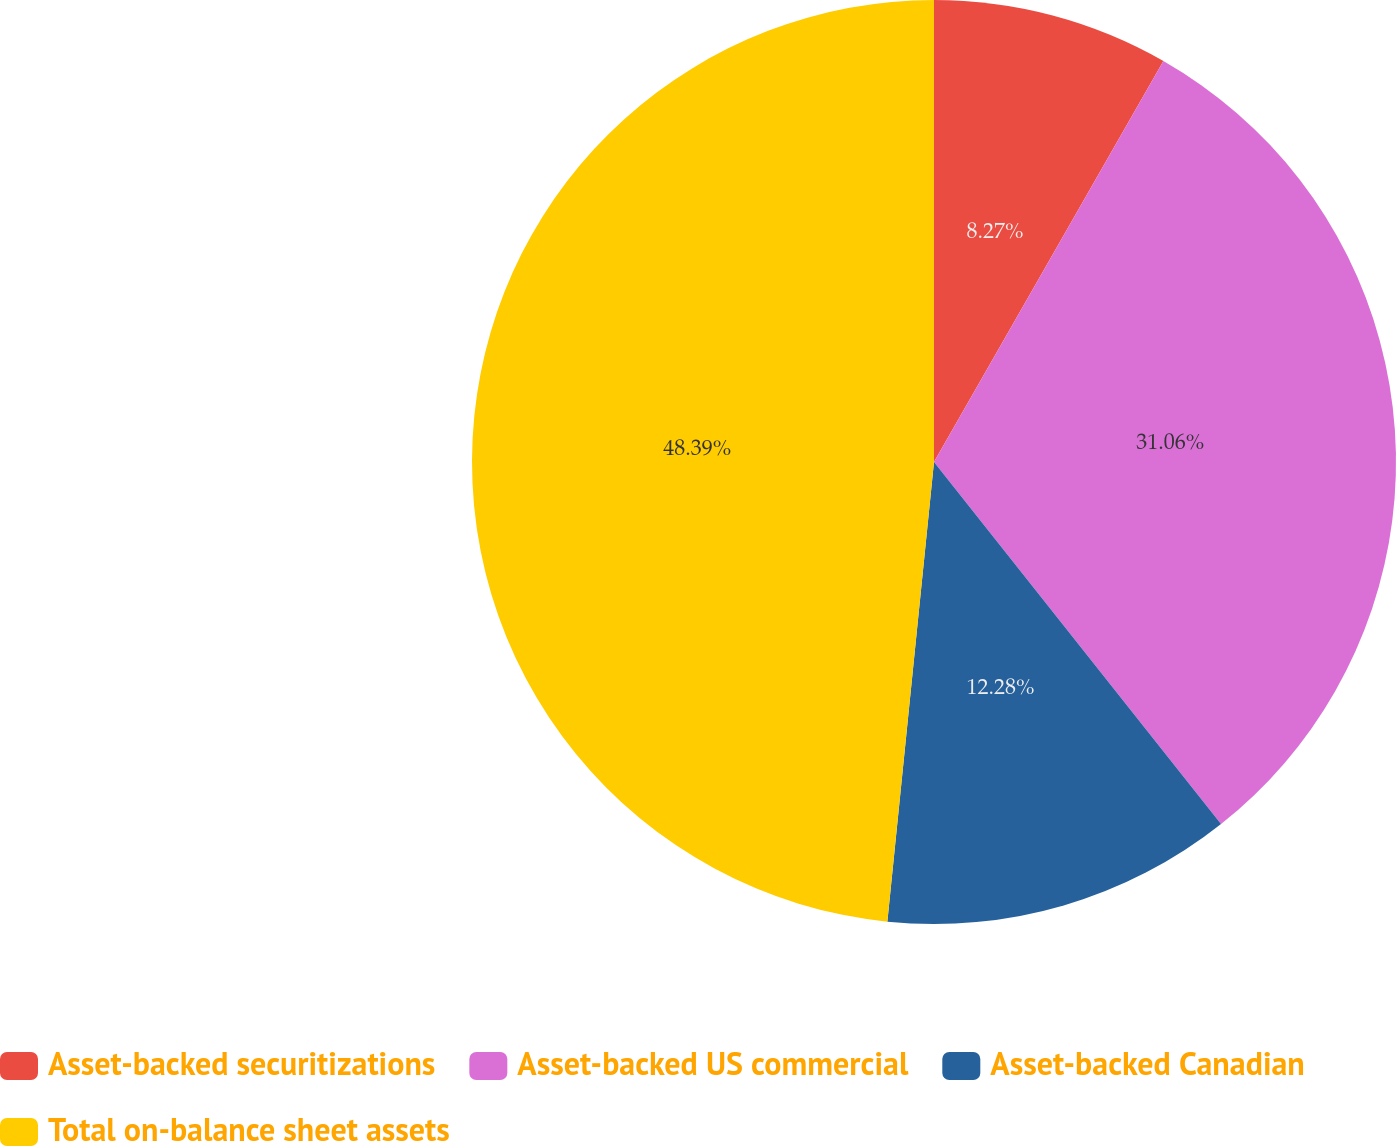Convert chart to OTSL. <chart><loc_0><loc_0><loc_500><loc_500><pie_chart><fcel>Asset-backed securitizations<fcel>Asset-backed US commercial<fcel>Asset-backed Canadian<fcel>Total on-balance sheet assets<nl><fcel>8.27%<fcel>31.06%<fcel>12.28%<fcel>48.39%<nl></chart> 